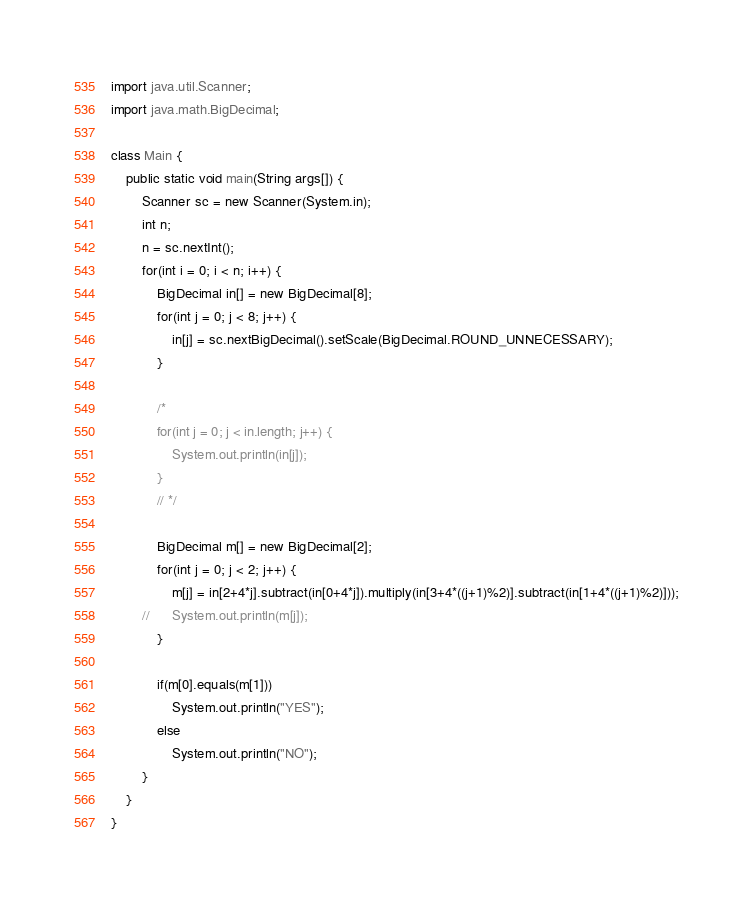<code> <loc_0><loc_0><loc_500><loc_500><_Java_>import java.util.Scanner;
import java.math.BigDecimal;

class Main {
	public static void main(String args[]) {
		Scanner sc = new Scanner(System.in);
		int n;
		n = sc.nextInt();
		for(int i = 0; i < n; i++) {
			BigDecimal in[] = new BigDecimal[8];
			for(int j = 0; j < 8; j++) {
				in[j] = sc.nextBigDecimal().setScale(BigDecimal.ROUND_UNNECESSARY);
			}

			/*
			for(int j = 0; j < in.length; j++) {
				System.out.println(in[j]);
			}
			// */

			BigDecimal m[] = new BigDecimal[2];
			for(int j = 0; j < 2; j++) {
				m[j] = in[2+4*j].subtract(in[0+4*j]).multiply(in[3+4*((j+1)%2)].subtract(in[1+4*((j+1)%2)]));
		//		System.out.println(m[j]);
			}

			if(m[0].equals(m[1]))
				System.out.println("YES");
			else
				System.out.println("NO");
		}
	}
}</code> 